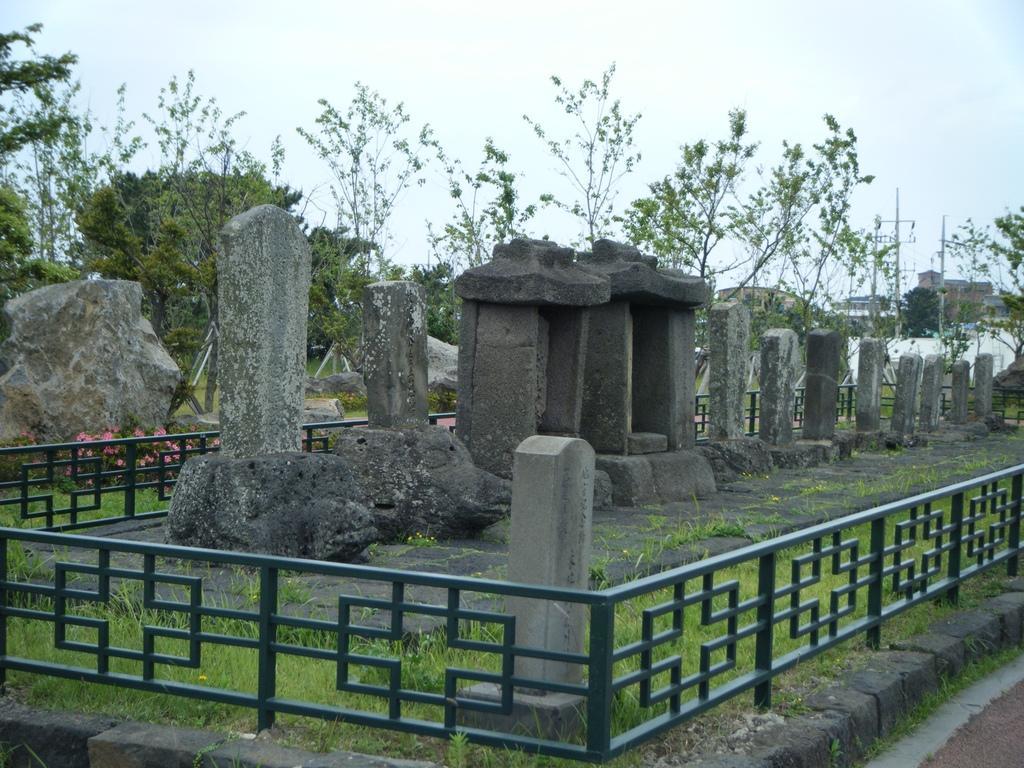Can you describe this image briefly? In this image, we can see grills around stones. There are some trees in the middle of the image. In the background of the image, there is a sky. 